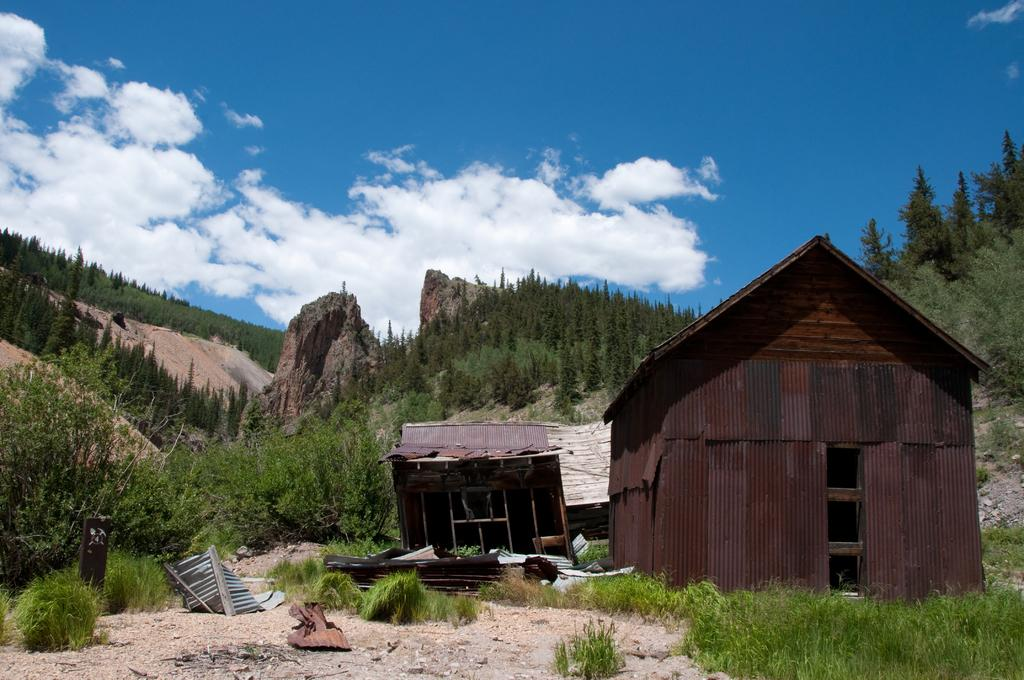What type of terrain is visible in the image? There is a land in the image. What can be found on the land? There are plants on the land. What structures can be seen in the background of the image? There are sheds in the background of the image. What type of vegetation is visible in the background of the image? There are trees in the background of the image. What natural features are visible in the background of the image? There are mountains in the background of the image. What is visible above the land and structures in the image? The sky is visible in the background of the image. What language is spoken by the van in the image? There is no van present in the image, so it is not possible to determine what language it might speak. 